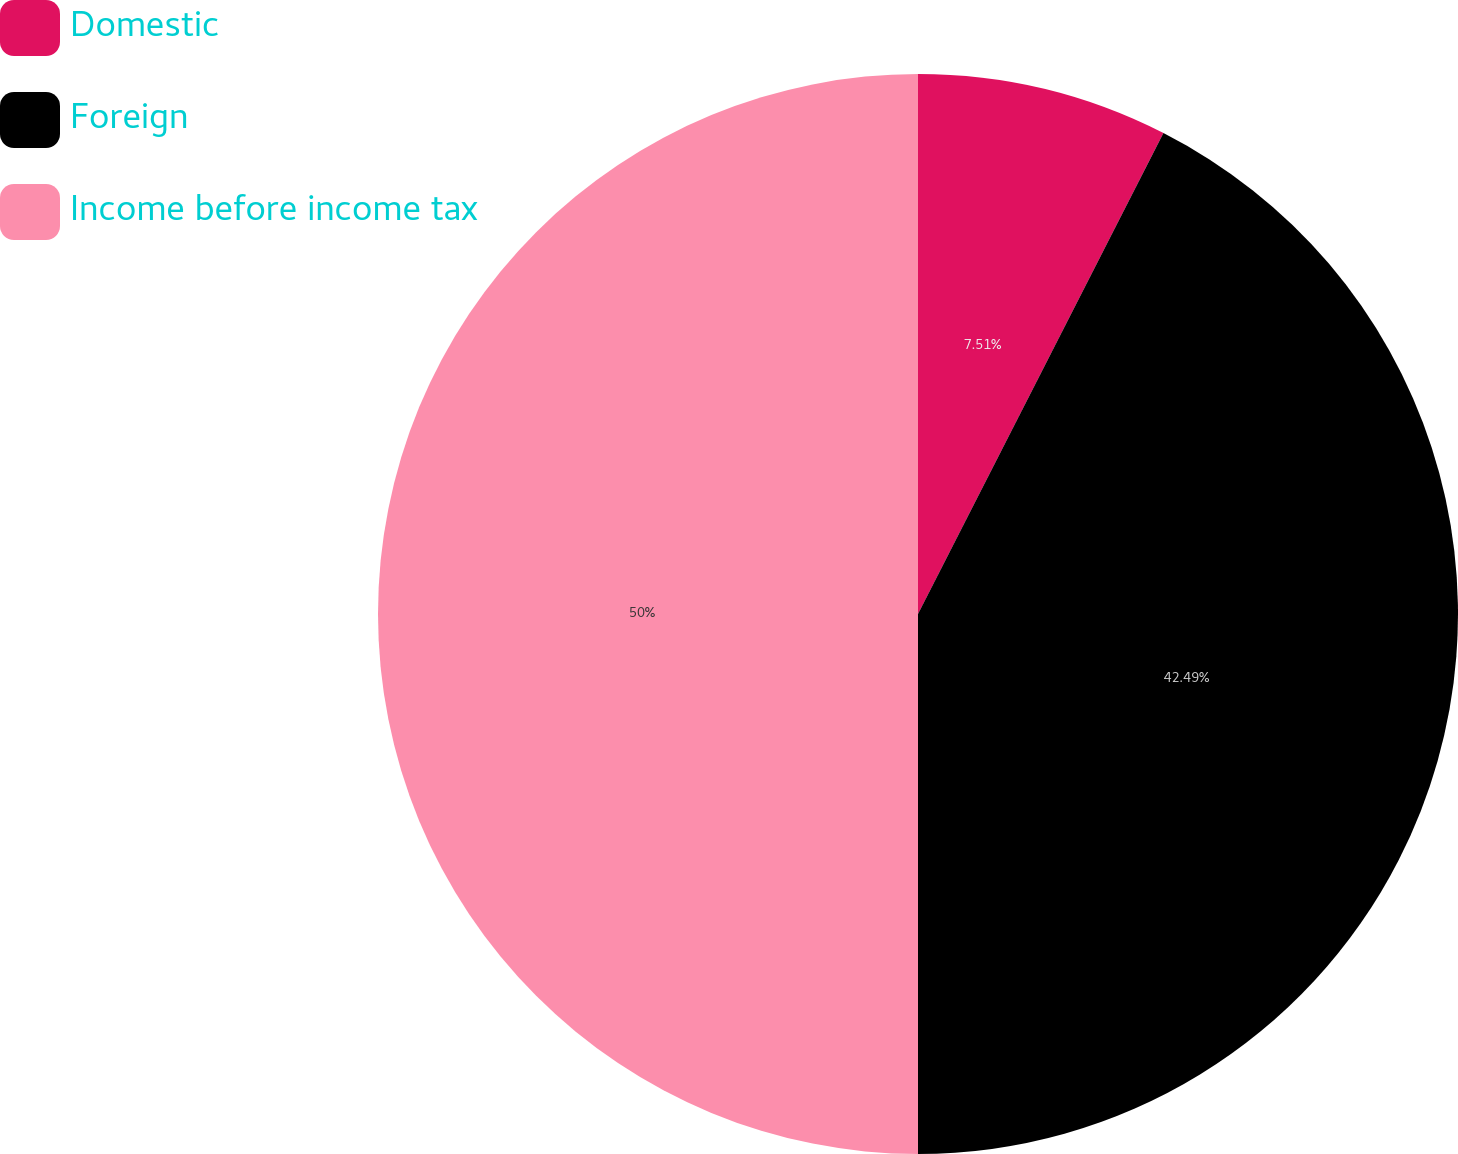<chart> <loc_0><loc_0><loc_500><loc_500><pie_chart><fcel>Domestic<fcel>Foreign<fcel>Income before income tax<nl><fcel>7.51%<fcel>42.49%<fcel>50.0%<nl></chart> 